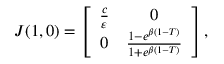<formula> <loc_0><loc_0><loc_500><loc_500>\begin{array} { r } { J ( 1 , 0 ) = \left [ { \begin{array} { c c } { \frac { c } { \varepsilon } } & { 0 } \\ { 0 } & { \frac { 1 - e ^ { \beta ( 1 - T ) } } { 1 + e ^ { \beta ( 1 - T ) } } } \end{array} } \right ] , } \end{array}</formula> 